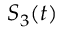Convert formula to latex. <formula><loc_0><loc_0><loc_500><loc_500>S _ { 3 } ( t )</formula> 